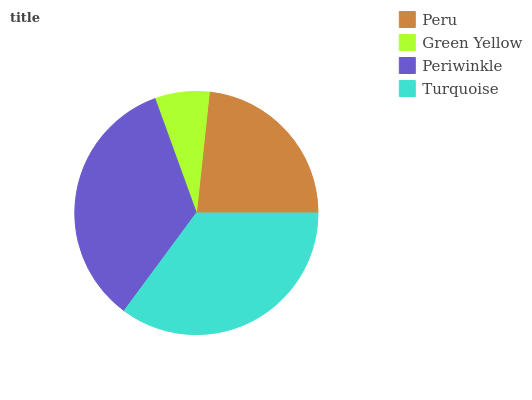Is Green Yellow the minimum?
Answer yes or no. Yes. Is Turquoise the maximum?
Answer yes or no. Yes. Is Periwinkle the minimum?
Answer yes or no. No. Is Periwinkle the maximum?
Answer yes or no. No. Is Periwinkle greater than Green Yellow?
Answer yes or no. Yes. Is Green Yellow less than Periwinkle?
Answer yes or no. Yes. Is Green Yellow greater than Periwinkle?
Answer yes or no. No. Is Periwinkle less than Green Yellow?
Answer yes or no. No. Is Periwinkle the high median?
Answer yes or no. Yes. Is Peru the low median?
Answer yes or no. Yes. Is Peru the high median?
Answer yes or no. No. Is Turquoise the low median?
Answer yes or no. No. 